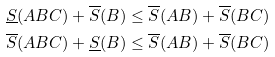<formula> <loc_0><loc_0><loc_500><loc_500>\underline { S } ( A B C ) + \overline { S } ( B ) & \leq \overline { S } ( A B ) + \overline { S } ( B C ) \\ \overline { S } ( A B C ) + \underline { S } ( B ) & \leq \overline { S } ( A B ) + \overline { S } ( B C )</formula> 